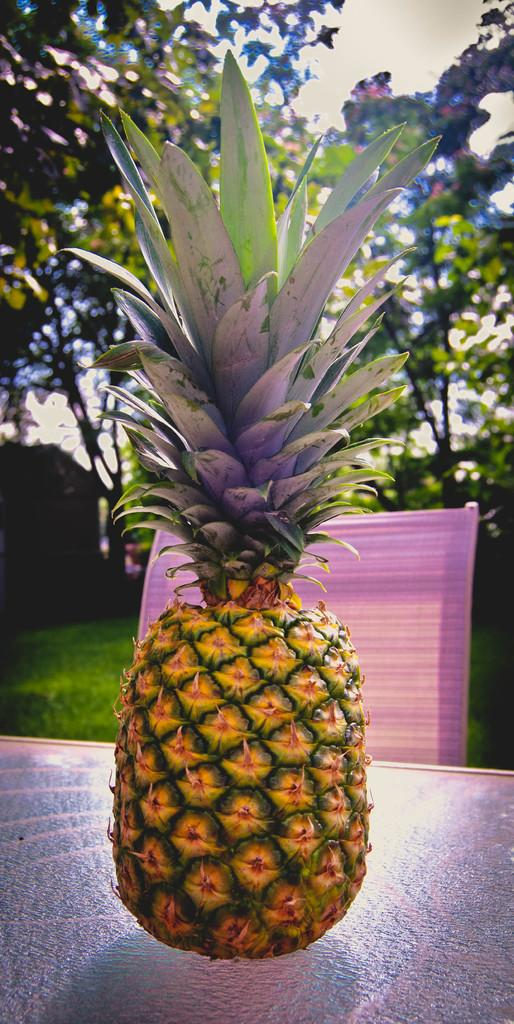What type of fruit is on the table in the image? There is a pineapple fruit on a table in the image. What is on the chair in the image? There is a cloth on a chair in the image. What can be seen in the background of the image? Trees, grass, and the sky are visible in the background of the image. What type of stone is being used as a cork in the image? There is no stone or cork present in the image; it features a pineapple fruit on a table and a cloth on a chair. 